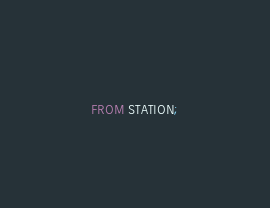Convert code to text. <code><loc_0><loc_0><loc_500><loc_500><_SQL_>FROM STATION;</code> 